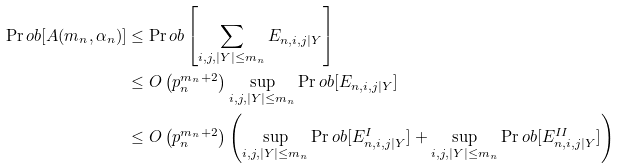<formula> <loc_0><loc_0><loc_500><loc_500>\Pr o b [ A ( m _ { n } , \alpha _ { n } ) ] & \leq \Pr o b \left [ \sum _ { i , j , | Y | \leq m _ { n } } E _ { n , i , j | Y } \right ] \\ & \leq O \left ( p ^ { m _ { n } + 2 } _ { n } \right ) \sup _ { i , j , | Y | \leq m _ { n } } \Pr o b [ E _ { n , i , j | Y } ] \\ & \leq O \left ( p ^ { m _ { n } + 2 } _ { n } \right ) \left ( \sup _ { i , j , | Y | \leq m _ { n } } \Pr o b [ E ^ { I } _ { n , i , j | Y } ] + \sup _ { i , j , | Y | \leq m _ { n } } \Pr o b [ E ^ { I I } _ { n , i , j | Y } ] \right )</formula> 